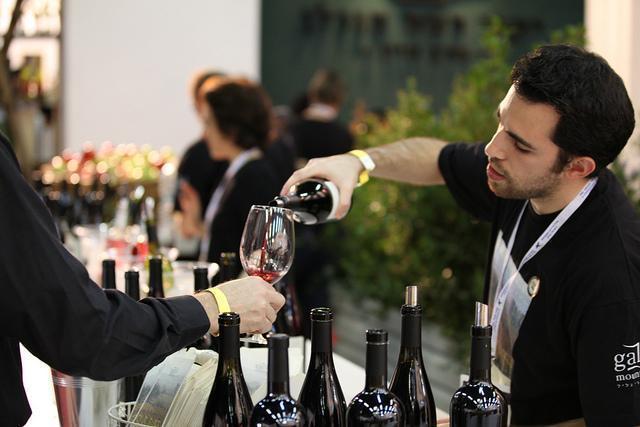How many bottles are there?
Give a very brief answer. 7. How many people are there?
Give a very brief answer. 5. How many giraffes are pictured?
Give a very brief answer. 0. 